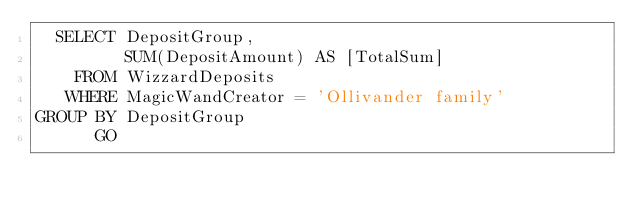<code> <loc_0><loc_0><loc_500><loc_500><_SQL_>  SELECT DepositGroup,
         SUM(DepositAmount) AS [TotalSum]
    FROM WizzardDeposits
   WHERE MagicWandCreator = 'Ollivander family'
GROUP BY DepositGroup
      GO</code> 